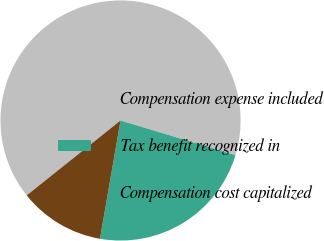<chart> <loc_0><loc_0><loc_500><loc_500><pie_chart><fcel>Compensation expense included<fcel>Tax benefit recognized in<fcel>Compensation cost capitalized<nl><fcel>65.38%<fcel>23.08%<fcel>11.54%<nl></chart> 